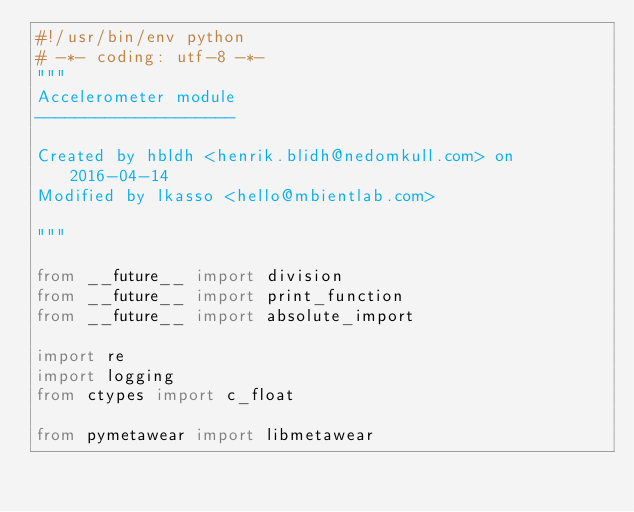<code> <loc_0><loc_0><loc_500><loc_500><_Python_>#!/usr/bin/env python
# -*- coding: utf-8 -*-
"""
Accelerometer module
--------------------

Created by hbldh <henrik.blidh@nedomkull.com> on 2016-04-14
Modified by lkasso <hello@mbientlab.com>

"""

from __future__ import division
from __future__ import print_function
from __future__ import absolute_import

import re
import logging
from ctypes import c_float

from pymetawear import libmetawear</code> 